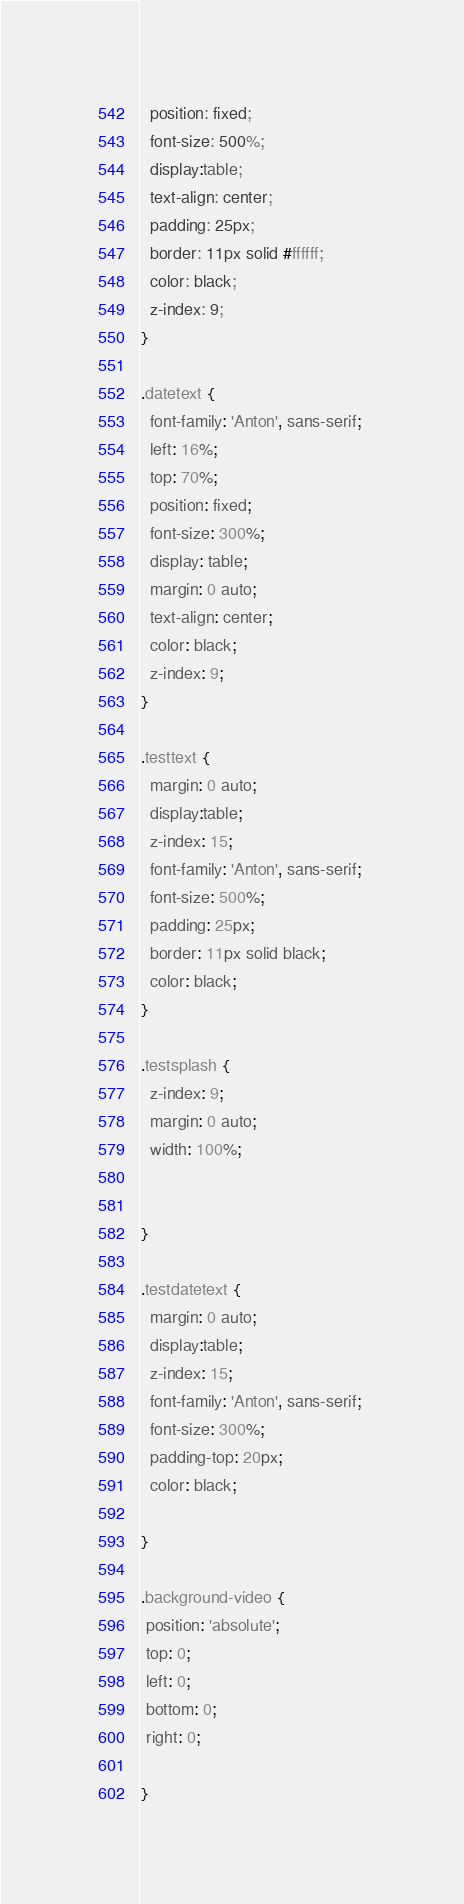<code> <loc_0><loc_0><loc_500><loc_500><_CSS_>  position: fixed;
  font-size: 500%;
  display:table;
  text-align: center;
  padding: 25px;
  border: 11px solid #ffffff;
  color: black;
  z-index: 9;
}

.datetext {
  font-family: 'Anton', sans-serif; 
  left: 16%;
  top: 70%;
  position: fixed;
  font-size: 300%;
  display: table;
  margin: 0 auto;
  text-align: center;
  color: black;
  z-index: 9;
}

.testtext {
  margin: 0 auto;
  display:table;
  z-index: 15;
  font-family: 'Anton', sans-serif;
  font-size: 500%;
  padding: 25px;
  border: 11px solid black;
  color: black;
}

.testsplash {
  z-index: 9;
  margin: 0 auto;
  width: 100%;


}

.testdatetext {
  margin: 0 auto;
  display:table;
  z-index: 15;
  font-family: 'Anton', sans-serif;
  font-size: 300%;
  padding-top: 20px;
  color: black;
  
}

.background-video {
 position: 'absolute';
 top: 0;
 left: 0;
 bottom: 0;
 right: 0;
 
}</code> 